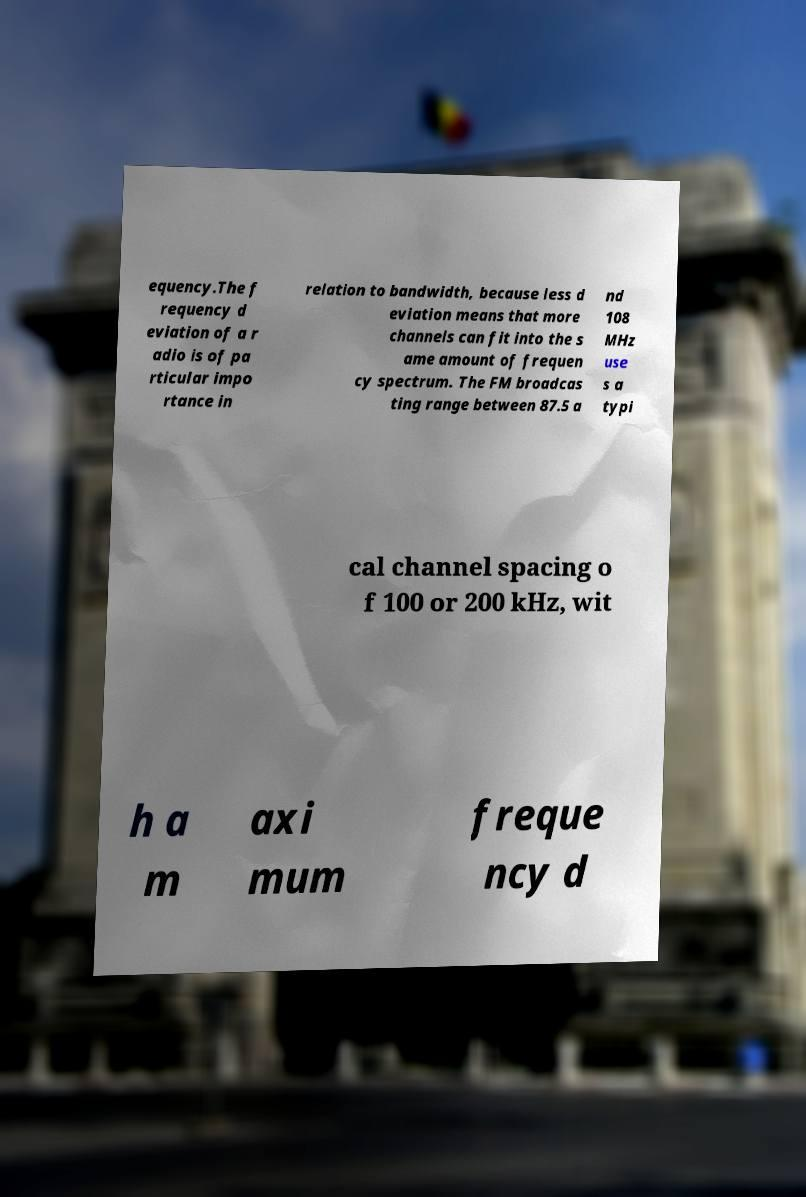Could you extract and type out the text from this image? equency.The f requency d eviation of a r adio is of pa rticular impo rtance in relation to bandwidth, because less d eviation means that more channels can fit into the s ame amount of frequen cy spectrum. The FM broadcas ting range between 87.5 a nd 108 MHz use s a typi cal channel spacing o f 100 or 200 kHz, wit h a m axi mum freque ncy d 